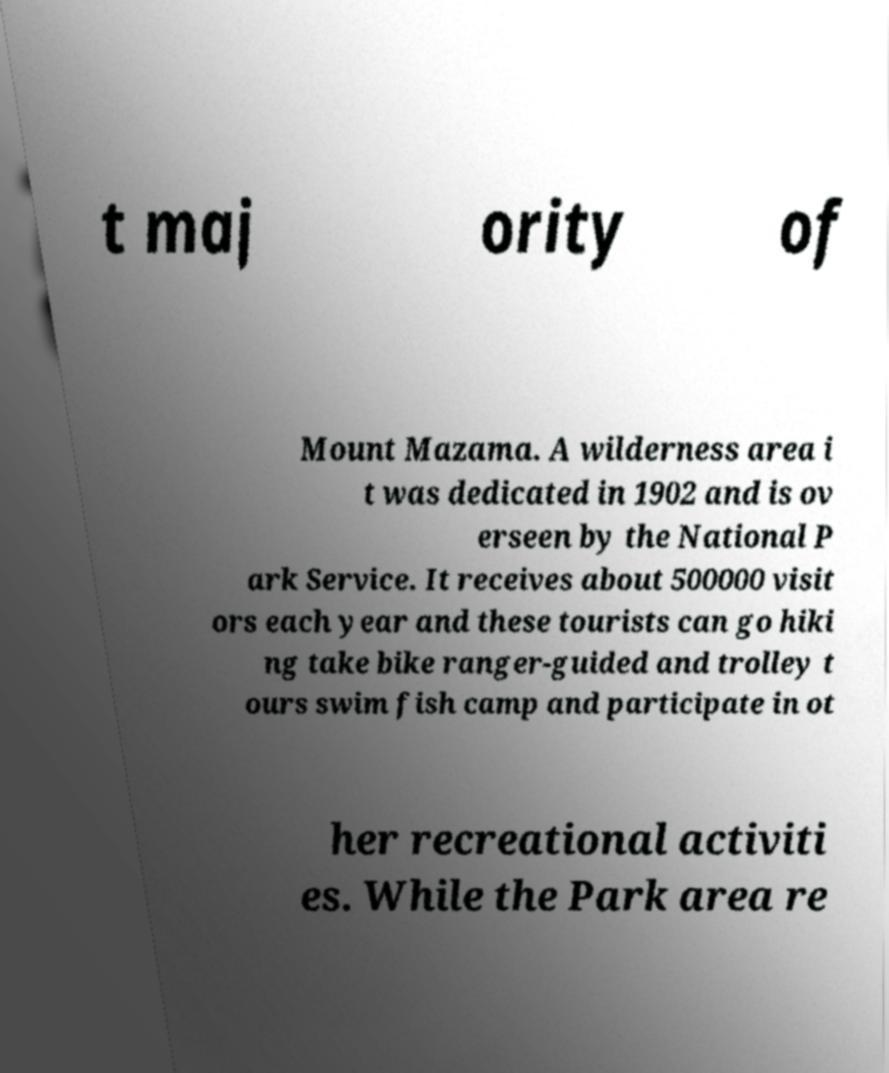Please read and relay the text visible in this image. What does it say? t maj ority of Mount Mazama. A wilderness area i t was dedicated in 1902 and is ov erseen by the National P ark Service. It receives about 500000 visit ors each year and these tourists can go hiki ng take bike ranger-guided and trolley t ours swim fish camp and participate in ot her recreational activiti es. While the Park area re 